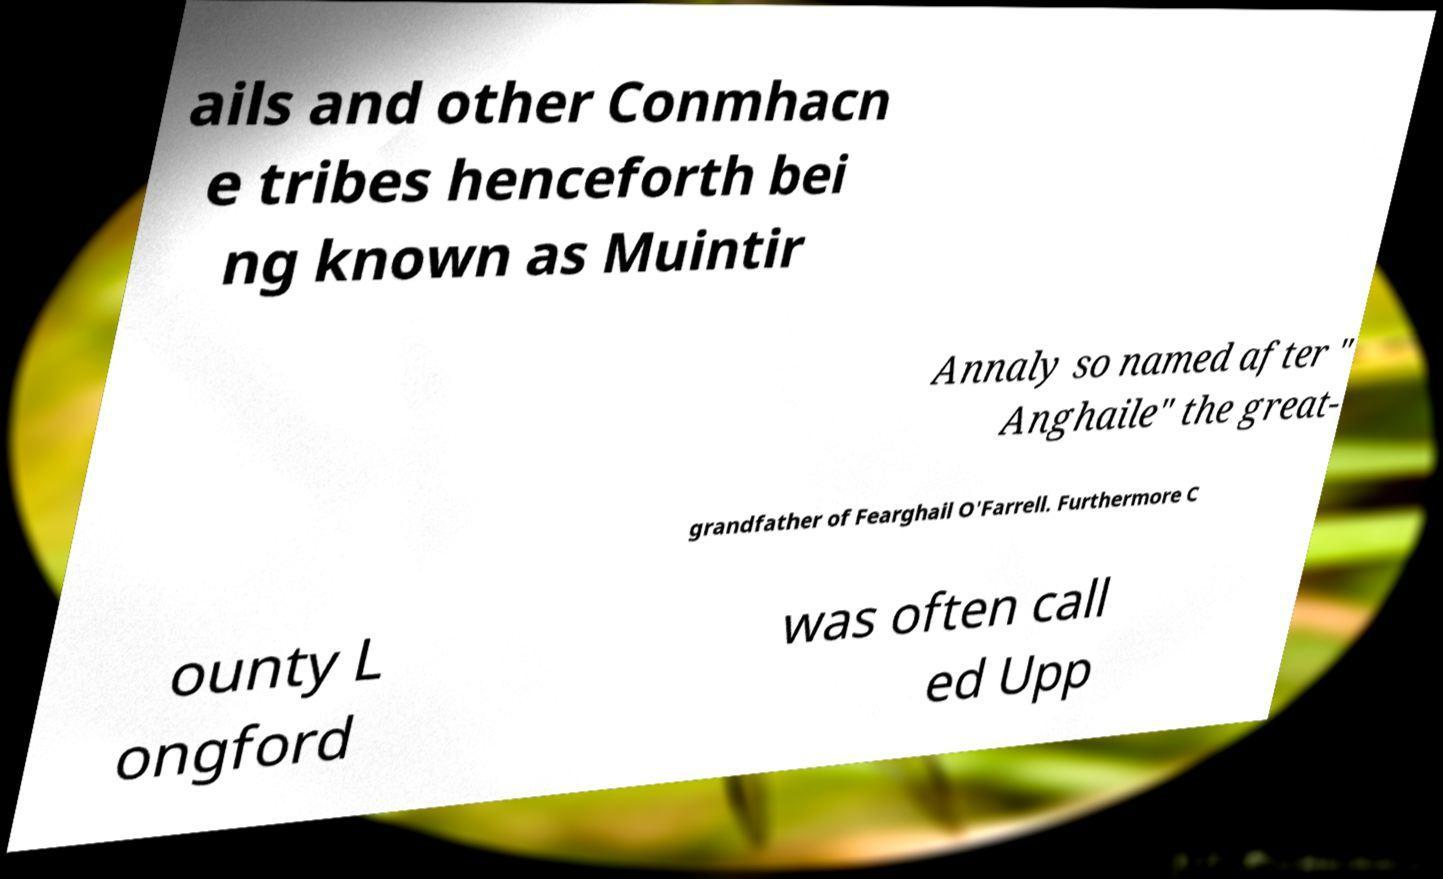I need the written content from this picture converted into text. Can you do that? ails and other Conmhacn e tribes henceforth bei ng known as Muintir Annaly so named after " Anghaile" the great- grandfather of Fearghail O'Farrell. Furthermore C ounty L ongford was often call ed Upp 